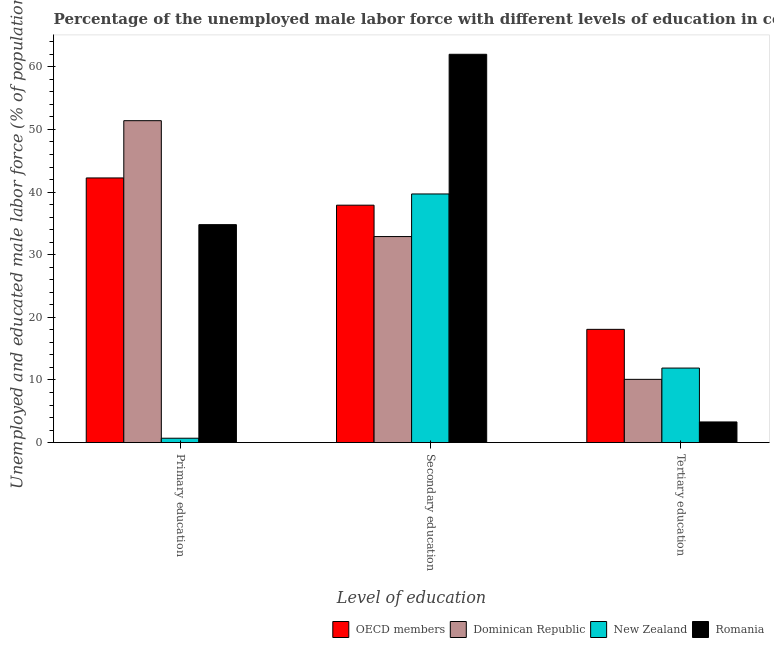Are the number of bars per tick equal to the number of legend labels?
Your response must be concise. Yes. Are the number of bars on each tick of the X-axis equal?
Keep it short and to the point. Yes. What is the label of the 2nd group of bars from the left?
Your response must be concise. Secondary education. What is the percentage of male labor force who received primary education in Dominican Republic?
Provide a succinct answer. 51.4. Across all countries, what is the maximum percentage of male labor force who received secondary education?
Ensure brevity in your answer.  62. Across all countries, what is the minimum percentage of male labor force who received primary education?
Provide a succinct answer. 0.7. In which country was the percentage of male labor force who received primary education maximum?
Offer a very short reply. Dominican Republic. In which country was the percentage of male labor force who received primary education minimum?
Your response must be concise. New Zealand. What is the total percentage of male labor force who received primary education in the graph?
Your answer should be very brief. 129.16. What is the difference between the percentage of male labor force who received primary education in Romania and that in New Zealand?
Your answer should be compact. 34.1. What is the difference between the percentage of male labor force who received tertiary education in Romania and the percentage of male labor force who received secondary education in New Zealand?
Give a very brief answer. -36.4. What is the average percentage of male labor force who received primary education per country?
Provide a short and direct response. 32.29. What is the difference between the percentage of male labor force who received secondary education and percentage of male labor force who received primary education in New Zealand?
Keep it short and to the point. 39. What is the ratio of the percentage of male labor force who received tertiary education in New Zealand to that in Romania?
Offer a very short reply. 3.61. Is the percentage of male labor force who received primary education in Dominican Republic less than that in Romania?
Provide a short and direct response. No. What is the difference between the highest and the second highest percentage of male labor force who received secondary education?
Make the answer very short. 22.3. What is the difference between the highest and the lowest percentage of male labor force who received secondary education?
Your answer should be compact. 29.1. In how many countries, is the percentage of male labor force who received tertiary education greater than the average percentage of male labor force who received tertiary education taken over all countries?
Your answer should be very brief. 2. What does the 2nd bar from the left in Primary education represents?
Give a very brief answer. Dominican Republic. What does the 1st bar from the right in Primary education represents?
Provide a succinct answer. Romania. Are all the bars in the graph horizontal?
Your response must be concise. No. How many countries are there in the graph?
Provide a succinct answer. 4. How many legend labels are there?
Your answer should be compact. 4. How are the legend labels stacked?
Your answer should be compact. Horizontal. What is the title of the graph?
Your answer should be very brief. Percentage of the unemployed male labor force with different levels of education in countries. Does "High income: OECD" appear as one of the legend labels in the graph?
Provide a succinct answer. No. What is the label or title of the X-axis?
Make the answer very short. Level of education. What is the label or title of the Y-axis?
Give a very brief answer. Unemployed and educated male labor force (% of population). What is the Unemployed and educated male labor force (% of population) of OECD members in Primary education?
Make the answer very short. 42.26. What is the Unemployed and educated male labor force (% of population) in Dominican Republic in Primary education?
Provide a succinct answer. 51.4. What is the Unemployed and educated male labor force (% of population) in New Zealand in Primary education?
Your answer should be very brief. 0.7. What is the Unemployed and educated male labor force (% of population) in Romania in Primary education?
Give a very brief answer. 34.8. What is the Unemployed and educated male labor force (% of population) in OECD members in Secondary education?
Provide a succinct answer. 37.91. What is the Unemployed and educated male labor force (% of population) in Dominican Republic in Secondary education?
Provide a short and direct response. 32.9. What is the Unemployed and educated male labor force (% of population) in New Zealand in Secondary education?
Give a very brief answer. 39.7. What is the Unemployed and educated male labor force (% of population) in OECD members in Tertiary education?
Offer a terse response. 18.08. What is the Unemployed and educated male labor force (% of population) of Dominican Republic in Tertiary education?
Provide a short and direct response. 10.1. What is the Unemployed and educated male labor force (% of population) of New Zealand in Tertiary education?
Keep it short and to the point. 11.9. What is the Unemployed and educated male labor force (% of population) of Romania in Tertiary education?
Your answer should be compact. 3.3. Across all Level of education, what is the maximum Unemployed and educated male labor force (% of population) of OECD members?
Your response must be concise. 42.26. Across all Level of education, what is the maximum Unemployed and educated male labor force (% of population) in Dominican Republic?
Provide a short and direct response. 51.4. Across all Level of education, what is the maximum Unemployed and educated male labor force (% of population) of New Zealand?
Your answer should be very brief. 39.7. Across all Level of education, what is the maximum Unemployed and educated male labor force (% of population) of Romania?
Offer a terse response. 62. Across all Level of education, what is the minimum Unemployed and educated male labor force (% of population) of OECD members?
Provide a succinct answer. 18.08. Across all Level of education, what is the minimum Unemployed and educated male labor force (% of population) of Dominican Republic?
Provide a succinct answer. 10.1. Across all Level of education, what is the minimum Unemployed and educated male labor force (% of population) in New Zealand?
Ensure brevity in your answer.  0.7. Across all Level of education, what is the minimum Unemployed and educated male labor force (% of population) of Romania?
Give a very brief answer. 3.3. What is the total Unemployed and educated male labor force (% of population) of OECD members in the graph?
Make the answer very short. 98.25. What is the total Unemployed and educated male labor force (% of population) of Dominican Republic in the graph?
Provide a succinct answer. 94.4. What is the total Unemployed and educated male labor force (% of population) in New Zealand in the graph?
Provide a short and direct response. 52.3. What is the total Unemployed and educated male labor force (% of population) of Romania in the graph?
Provide a succinct answer. 100.1. What is the difference between the Unemployed and educated male labor force (% of population) in OECD members in Primary education and that in Secondary education?
Make the answer very short. 4.35. What is the difference between the Unemployed and educated male labor force (% of population) of Dominican Republic in Primary education and that in Secondary education?
Your response must be concise. 18.5. What is the difference between the Unemployed and educated male labor force (% of population) of New Zealand in Primary education and that in Secondary education?
Your answer should be compact. -39. What is the difference between the Unemployed and educated male labor force (% of population) of Romania in Primary education and that in Secondary education?
Offer a very short reply. -27.2. What is the difference between the Unemployed and educated male labor force (% of population) in OECD members in Primary education and that in Tertiary education?
Keep it short and to the point. 24.18. What is the difference between the Unemployed and educated male labor force (% of population) of Dominican Republic in Primary education and that in Tertiary education?
Provide a short and direct response. 41.3. What is the difference between the Unemployed and educated male labor force (% of population) of New Zealand in Primary education and that in Tertiary education?
Make the answer very short. -11.2. What is the difference between the Unemployed and educated male labor force (% of population) of Romania in Primary education and that in Tertiary education?
Offer a very short reply. 31.5. What is the difference between the Unemployed and educated male labor force (% of population) in OECD members in Secondary education and that in Tertiary education?
Provide a succinct answer. 19.83. What is the difference between the Unemployed and educated male labor force (% of population) of Dominican Republic in Secondary education and that in Tertiary education?
Provide a short and direct response. 22.8. What is the difference between the Unemployed and educated male labor force (% of population) of New Zealand in Secondary education and that in Tertiary education?
Offer a very short reply. 27.8. What is the difference between the Unemployed and educated male labor force (% of population) in Romania in Secondary education and that in Tertiary education?
Make the answer very short. 58.7. What is the difference between the Unemployed and educated male labor force (% of population) of OECD members in Primary education and the Unemployed and educated male labor force (% of population) of Dominican Republic in Secondary education?
Offer a very short reply. 9.36. What is the difference between the Unemployed and educated male labor force (% of population) in OECD members in Primary education and the Unemployed and educated male labor force (% of population) in New Zealand in Secondary education?
Your answer should be very brief. 2.56. What is the difference between the Unemployed and educated male labor force (% of population) in OECD members in Primary education and the Unemployed and educated male labor force (% of population) in Romania in Secondary education?
Offer a terse response. -19.74. What is the difference between the Unemployed and educated male labor force (% of population) of Dominican Republic in Primary education and the Unemployed and educated male labor force (% of population) of Romania in Secondary education?
Provide a succinct answer. -10.6. What is the difference between the Unemployed and educated male labor force (% of population) in New Zealand in Primary education and the Unemployed and educated male labor force (% of population) in Romania in Secondary education?
Ensure brevity in your answer.  -61.3. What is the difference between the Unemployed and educated male labor force (% of population) in OECD members in Primary education and the Unemployed and educated male labor force (% of population) in Dominican Republic in Tertiary education?
Provide a short and direct response. 32.16. What is the difference between the Unemployed and educated male labor force (% of population) of OECD members in Primary education and the Unemployed and educated male labor force (% of population) of New Zealand in Tertiary education?
Provide a short and direct response. 30.36. What is the difference between the Unemployed and educated male labor force (% of population) of OECD members in Primary education and the Unemployed and educated male labor force (% of population) of Romania in Tertiary education?
Your answer should be compact. 38.96. What is the difference between the Unemployed and educated male labor force (% of population) of Dominican Republic in Primary education and the Unemployed and educated male labor force (% of population) of New Zealand in Tertiary education?
Your answer should be compact. 39.5. What is the difference between the Unemployed and educated male labor force (% of population) of Dominican Republic in Primary education and the Unemployed and educated male labor force (% of population) of Romania in Tertiary education?
Your answer should be very brief. 48.1. What is the difference between the Unemployed and educated male labor force (% of population) of OECD members in Secondary education and the Unemployed and educated male labor force (% of population) of Dominican Republic in Tertiary education?
Ensure brevity in your answer.  27.81. What is the difference between the Unemployed and educated male labor force (% of population) of OECD members in Secondary education and the Unemployed and educated male labor force (% of population) of New Zealand in Tertiary education?
Offer a terse response. 26.01. What is the difference between the Unemployed and educated male labor force (% of population) in OECD members in Secondary education and the Unemployed and educated male labor force (% of population) in Romania in Tertiary education?
Give a very brief answer. 34.61. What is the difference between the Unemployed and educated male labor force (% of population) of Dominican Republic in Secondary education and the Unemployed and educated male labor force (% of population) of Romania in Tertiary education?
Ensure brevity in your answer.  29.6. What is the difference between the Unemployed and educated male labor force (% of population) in New Zealand in Secondary education and the Unemployed and educated male labor force (% of population) in Romania in Tertiary education?
Your answer should be compact. 36.4. What is the average Unemployed and educated male labor force (% of population) of OECD members per Level of education?
Make the answer very short. 32.75. What is the average Unemployed and educated male labor force (% of population) in Dominican Republic per Level of education?
Provide a succinct answer. 31.47. What is the average Unemployed and educated male labor force (% of population) of New Zealand per Level of education?
Your answer should be compact. 17.43. What is the average Unemployed and educated male labor force (% of population) in Romania per Level of education?
Your answer should be compact. 33.37. What is the difference between the Unemployed and educated male labor force (% of population) of OECD members and Unemployed and educated male labor force (% of population) of Dominican Republic in Primary education?
Keep it short and to the point. -9.14. What is the difference between the Unemployed and educated male labor force (% of population) of OECD members and Unemployed and educated male labor force (% of population) of New Zealand in Primary education?
Offer a terse response. 41.56. What is the difference between the Unemployed and educated male labor force (% of population) of OECD members and Unemployed and educated male labor force (% of population) of Romania in Primary education?
Make the answer very short. 7.46. What is the difference between the Unemployed and educated male labor force (% of population) in Dominican Republic and Unemployed and educated male labor force (% of population) in New Zealand in Primary education?
Your answer should be very brief. 50.7. What is the difference between the Unemployed and educated male labor force (% of population) in New Zealand and Unemployed and educated male labor force (% of population) in Romania in Primary education?
Provide a succinct answer. -34.1. What is the difference between the Unemployed and educated male labor force (% of population) of OECD members and Unemployed and educated male labor force (% of population) of Dominican Republic in Secondary education?
Make the answer very short. 5.01. What is the difference between the Unemployed and educated male labor force (% of population) of OECD members and Unemployed and educated male labor force (% of population) of New Zealand in Secondary education?
Ensure brevity in your answer.  -1.79. What is the difference between the Unemployed and educated male labor force (% of population) of OECD members and Unemployed and educated male labor force (% of population) of Romania in Secondary education?
Give a very brief answer. -24.09. What is the difference between the Unemployed and educated male labor force (% of population) in Dominican Republic and Unemployed and educated male labor force (% of population) in New Zealand in Secondary education?
Ensure brevity in your answer.  -6.8. What is the difference between the Unemployed and educated male labor force (% of population) in Dominican Republic and Unemployed and educated male labor force (% of population) in Romania in Secondary education?
Your response must be concise. -29.1. What is the difference between the Unemployed and educated male labor force (% of population) of New Zealand and Unemployed and educated male labor force (% of population) of Romania in Secondary education?
Provide a short and direct response. -22.3. What is the difference between the Unemployed and educated male labor force (% of population) of OECD members and Unemployed and educated male labor force (% of population) of Dominican Republic in Tertiary education?
Give a very brief answer. 7.98. What is the difference between the Unemployed and educated male labor force (% of population) of OECD members and Unemployed and educated male labor force (% of population) of New Zealand in Tertiary education?
Make the answer very short. 6.18. What is the difference between the Unemployed and educated male labor force (% of population) of OECD members and Unemployed and educated male labor force (% of population) of Romania in Tertiary education?
Keep it short and to the point. 14.78. What is the difference between the Unemployed and educated male labor force (% of population) in Dominican Republic and Unemployed and educated male labor force (% of population) in New Zealand in Tertiary education?
Provide a short and direct response. -1.8. What is the difference between the Unemployed and educated male labor force (% of population) of Dominican Republic and Unemployed and educated male labor force (% of population) of Romania in Tertiary education?
Offer a terse response. 6.8. What is the difference between the Unemployed and educated male labor force (% of population) in New Zealand and Unemployed and educated male labor force (% of population) in Romania in Tertiary education?
Offer a terse response. 8.6. What is the ratio of the Unemployed and educated male labor force (% of population) in OECD members in Primary education to that in Secondary education?
Your answer should be very brief. 1.11. What is the ratio of the Unemployed and educated male labor force (% of population) of Dominican Republic in Primary education to that in Secondary education?
Your answer should be very brief. 1.56. What is the ratio of the Unemployed and educated male labor force (% of population) of New Zealand in Primary education to that in Secondary education?
Offer a terse response. 0.02. What is the ratio of the Unemployed and educated male labor force (% of population) of Romania in Primary education to that in Secondary education?
Keep it short and to the point. 0.56. What is the ratio of the Unemployed and educated male labor force (% of population) in OECD members in Primary education to that in Tertiary education?
Your answer should be very brief. 2.34. What is the ratio of the Unemployed and educated male labor force (% of population) of Dominican Republic in Primary education to that in Tertiary education?
Ensure brevity in your answer.  5.09. What is the ratio of the Unemployed and educated male labor force (% of population) of New Zealand in Primary education to that in Tertiary education?
Your response must be concise. 0.06. What is the ratio of the Unemployed and educated male labor force (% of population) in Romania in Primary education to that in Tertiary education?
Provide a succinct answer. 10.55. What is the ratio of the Unemployed and educated male labor force (% of population) of OECD members in Secondary education to that in Tertiary education?
Ensure brevity in your answer.  2.1. What is the ratio of the Unemployed and educated male labor force (% of population) of Dominican Republic in Secondary education to that in Tertiary education?
Offer a terse response. 3.26. What is the ratio of the Unemployed and educated male labor force (% of population) in New Zealand in Secondary education to that in Tertiary education?
Provide a succinct answer. 3.34. What is the ratio of the Unemployed and educated male labor force (% of population) of Romania in Secondary education to that in Tertiary education?
Your response must be concise. 18.79. What is the difference between the highest and the second highest Unemployed and educated male labor force (% of population) of OECD members?
Offer a terse response. 4.35. What is the difference between the highest and the second highest Unemployed and educated male labor force (% of population) in New Zealand?
Offer a very short reply. 27.8. What is the difference between the highest and the second highest Unemployed and educated male labor force (% of population) in Romania?
Make the answer very short. 27.2. What is the difference between the highest and the lowest Unemployed and educated male labor force (% of population) in OECD members?
Your answer should be compact. 24.18. What is the difference between the highest and the lowest Unemployed and educated male labor force (% of population) of Dominican Republic?
Ensure brevity in your answer.  41.3. What is the difference between the highest and the lowest Unemployed and educated male labor force (% of population) in New Zealand?
Your answer should be compact. 39. What is the difference between the highest and the lowest Unemployed and educated male labor force (% of population) in Romania?
Your response must be concise. 58.7. 